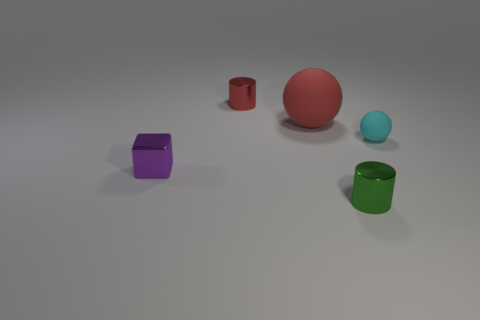Are there any yellow cubes made of the same material as the purple thing? Upon examining the image, I can confirm that there are no yellow cubes present. All the objects, including the purple cube, appear to be made of a similar matte material with a consistent finish and reflectivity. The objects vary in color and shape, with the purple cube being the sole object of its color and form. 